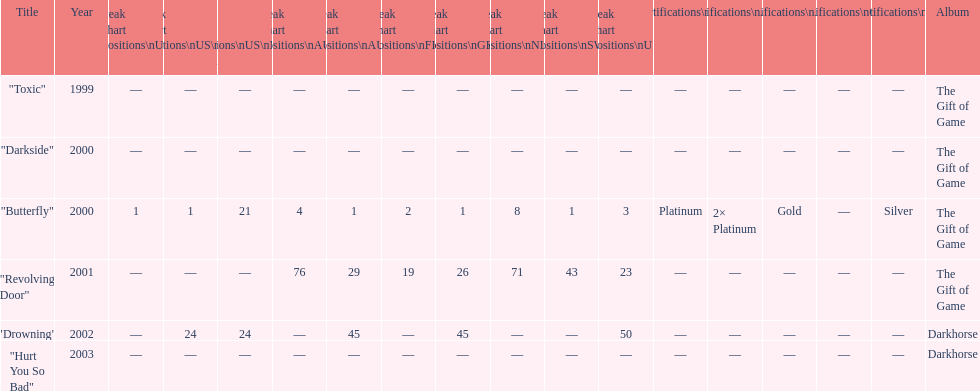How many times did the single "butterfly" rank as 1 in the chart? 5. 